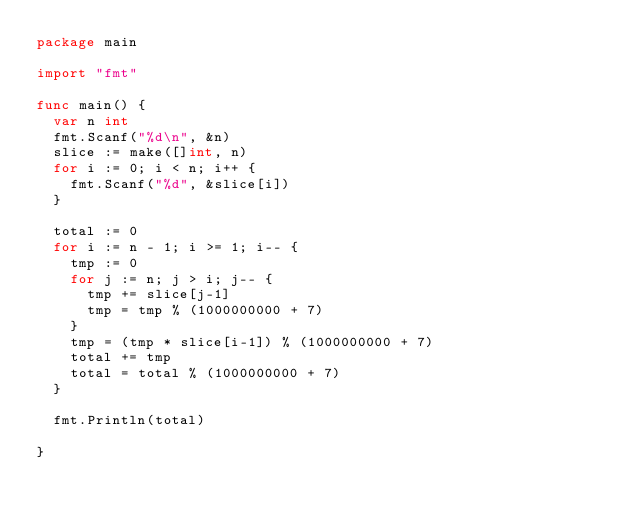<code> <loc_0><loc_0><loc_500><loc_500><_Go_>package main

import "fmt"

func main() {
	var n int
	fmt.Scanf("%d\n", &n)
	slice := make([]int, n)
	for i := 0; i < n; i++ {
		fmt.Scanf("%d", &slice[i])
	}

	total := 0
	for i := n - 1; i >= 1; i-- {
		tmp := 0
		for j := n; j > i; j-- {
			tmp += slice[j-1]
			tmp = tmp % (1000000000 + 7)
		}
		tmp = (tmp * slice[i-1]) % (1000000000 + 7)
		total += tmp
		total = total % (1000000000 + 7)
	}

	fmt.Println(total)

}
</code> 